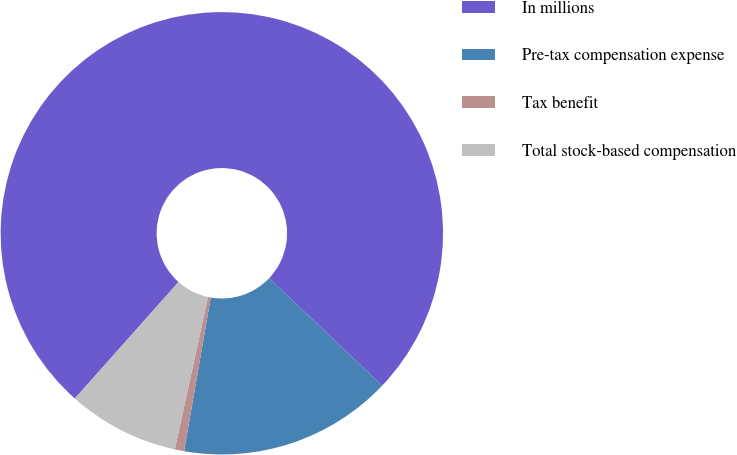<chart> <loc_0><loc_0><loc_500><loc_500><pie_chart><fcel>In millions<fcel>Pre-tax compensation expense<fcel>Tax benefit<fcel>Total stock-based compensation<nl><fcel>75.52%<fcel>15.64%<fcel>0.68%<fcel>8.16%<nl></chart> 